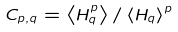Convert formula to latex. <formula><loc_0><loc_0><loc_500><loc_500>C _ { p , q } = \left < H _ { q } ^ { p } \right > / \left < H _ { q } \right > ^ { p }</formula> 